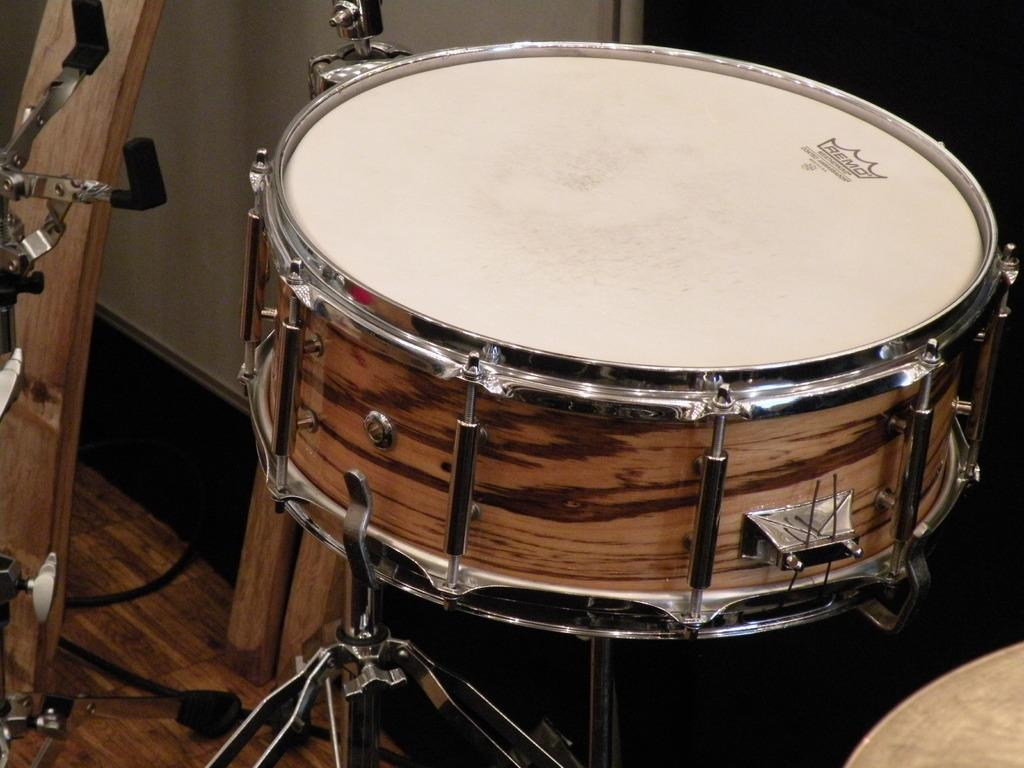What musical instrument is present in the image? There is a drum in the image. What else can be seen in the image besides the drum? There are stands and wooden objects visible in the image. Are there any wires on the floor in the image? Yes, there are wires on the floor in the image. What can be seen in the background of the image? There is a wall visible in the background of the image. How many facts can be seen with the eyes in the image? There is no reference to facts or eyes in the image; it features a drum, stands, wooden objects, wires on the floor, and a wall in the background. 